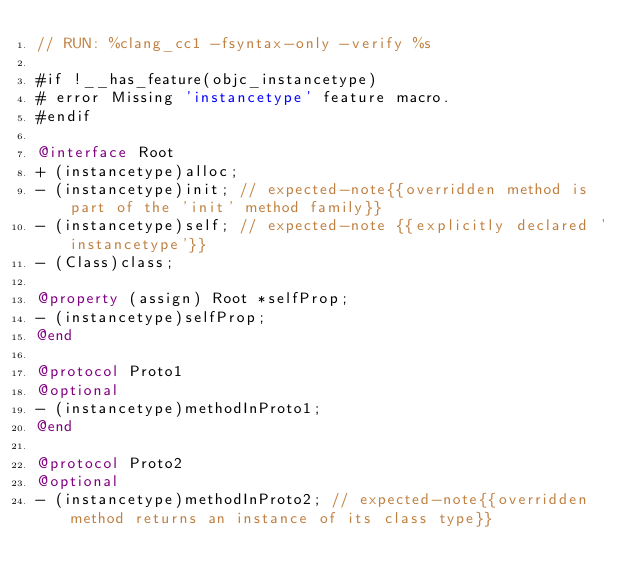<code> <loc_0><loc_0><loc_500><loc_500><_ObjectiveC_>// RUN: %clang_cc1 -fsyntax-only -verify %s

#if !__has_feature(objc_instancetype)
# error Missing 'instancetype' feature macro.
#endif

@interface Root
+ (instancetype)alloc;
- (instancetype)init; // expected-note{{overridden method is part of the 'init' method family}}
- (instancetype)self; // expected-note {{explicitly declared 'instancetype'}}
- (Class)class;

@property (assign) Root *selfProp;
- (instancetype)selfProp;
@end

@protocol Proto1
@optional
- (instancetype)methodInProto1;
@end

@protocol Proto2
@optional
- (instancetype)methodInProto2; // expected-note{{overridden method returns an instance of its class type}}</code> 